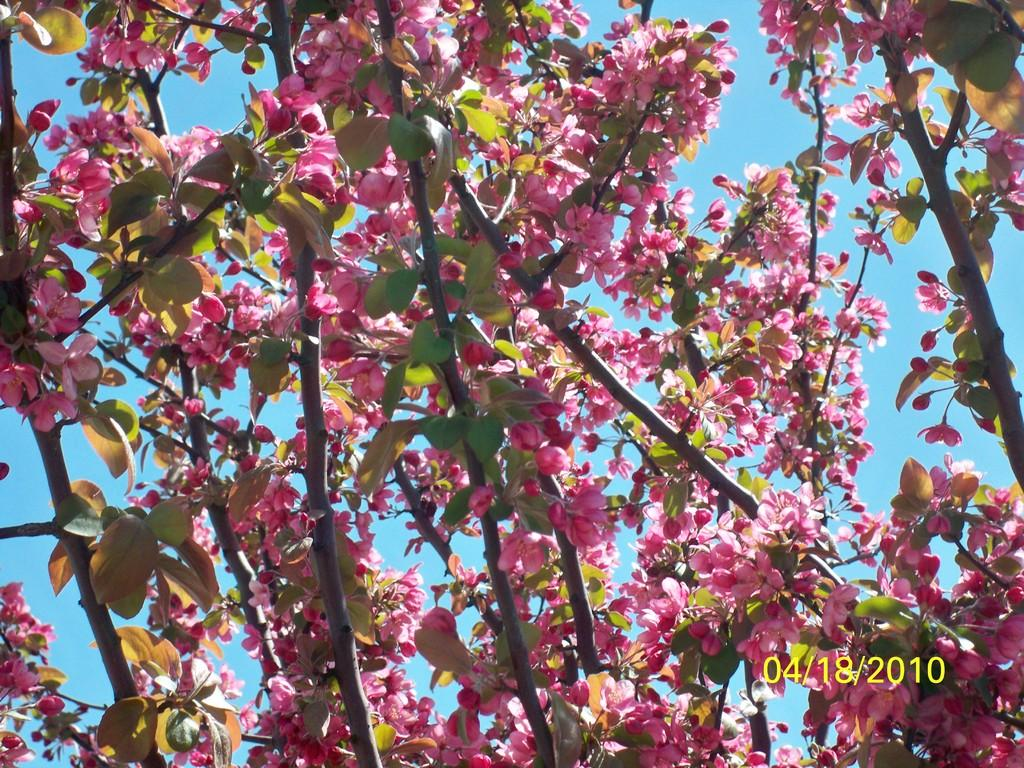What type of vegetation can be seen in the image? There are trees and flowers in the image. What is visible behind the trees in the image? The sky is visible behind the trees in the image. What type of cloth is draped over the hill in the image? There is no hill or cloth present in the image. 